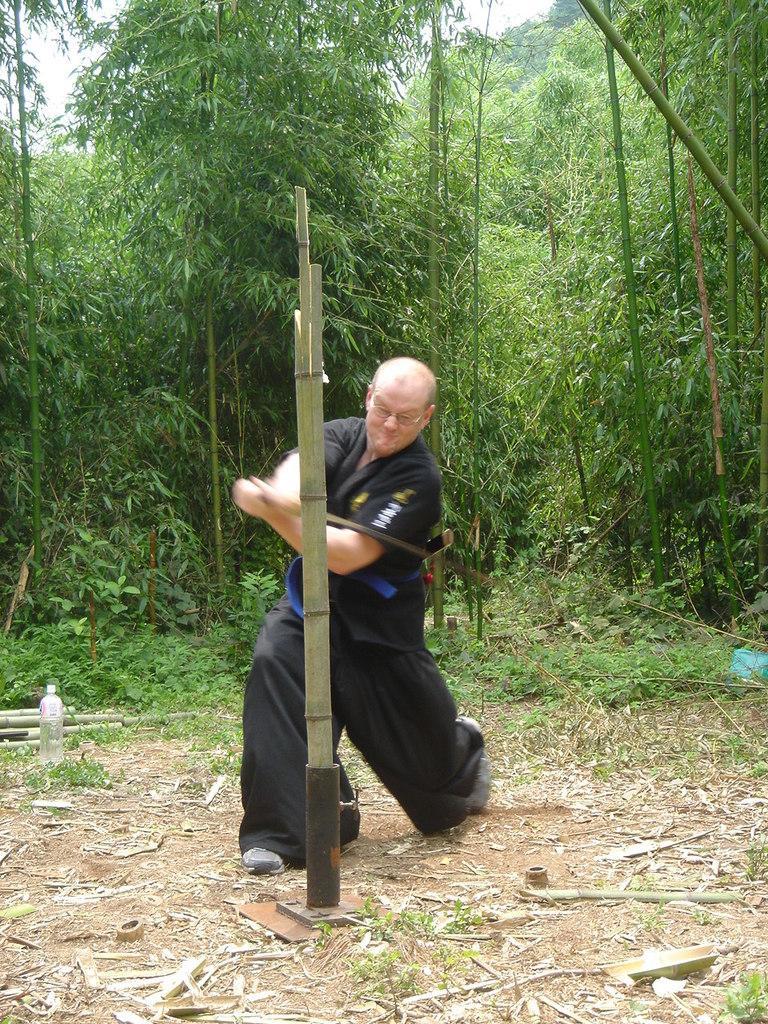Can you describe this image briefly? In the picture we can see a man standing and he is in martial arts dress and he is holding a sword and cutting a bamboo which is on the path and behind them we can see some plants and bamboo trees and some part of the sky. 